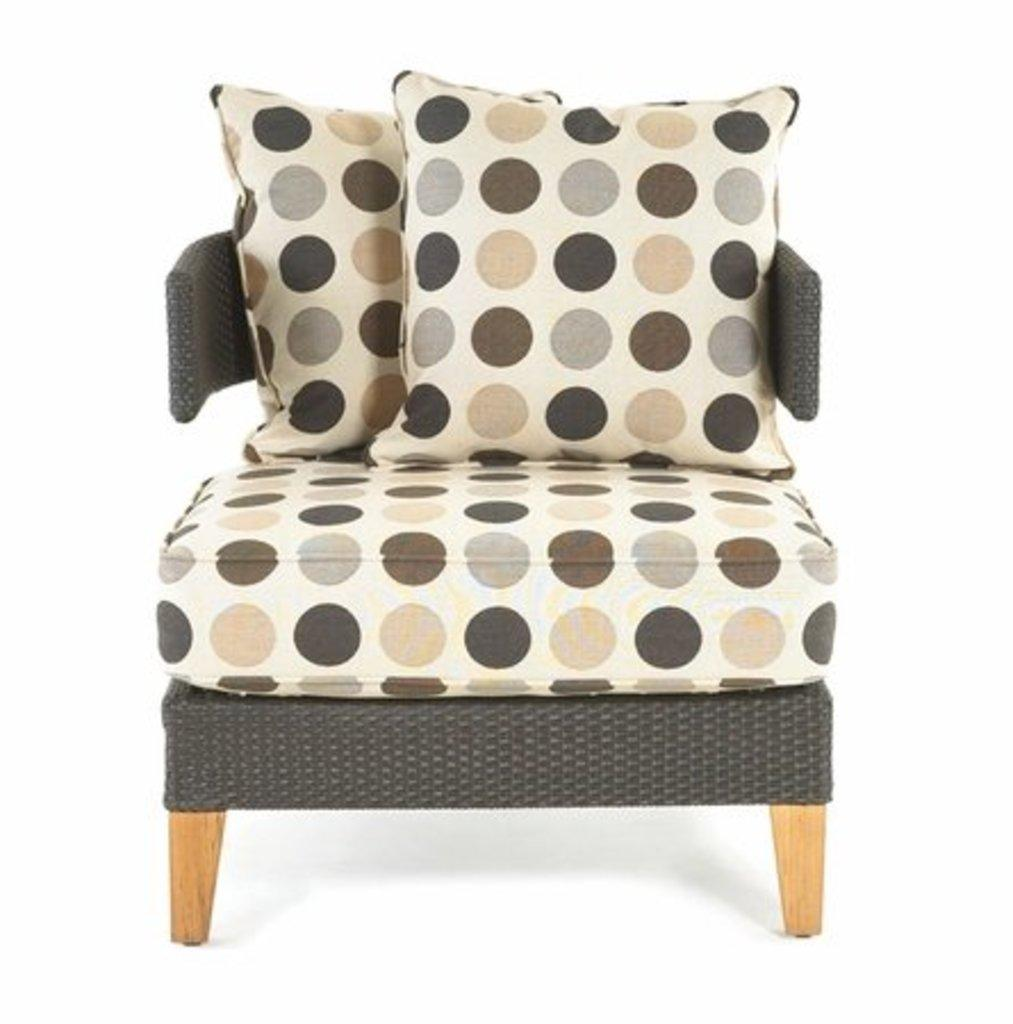What type of furniture is present in the image? There is a chair in the image. What type of jam is being mined in the image? There is no jam or mining activity present in the image; it only features a chair. 